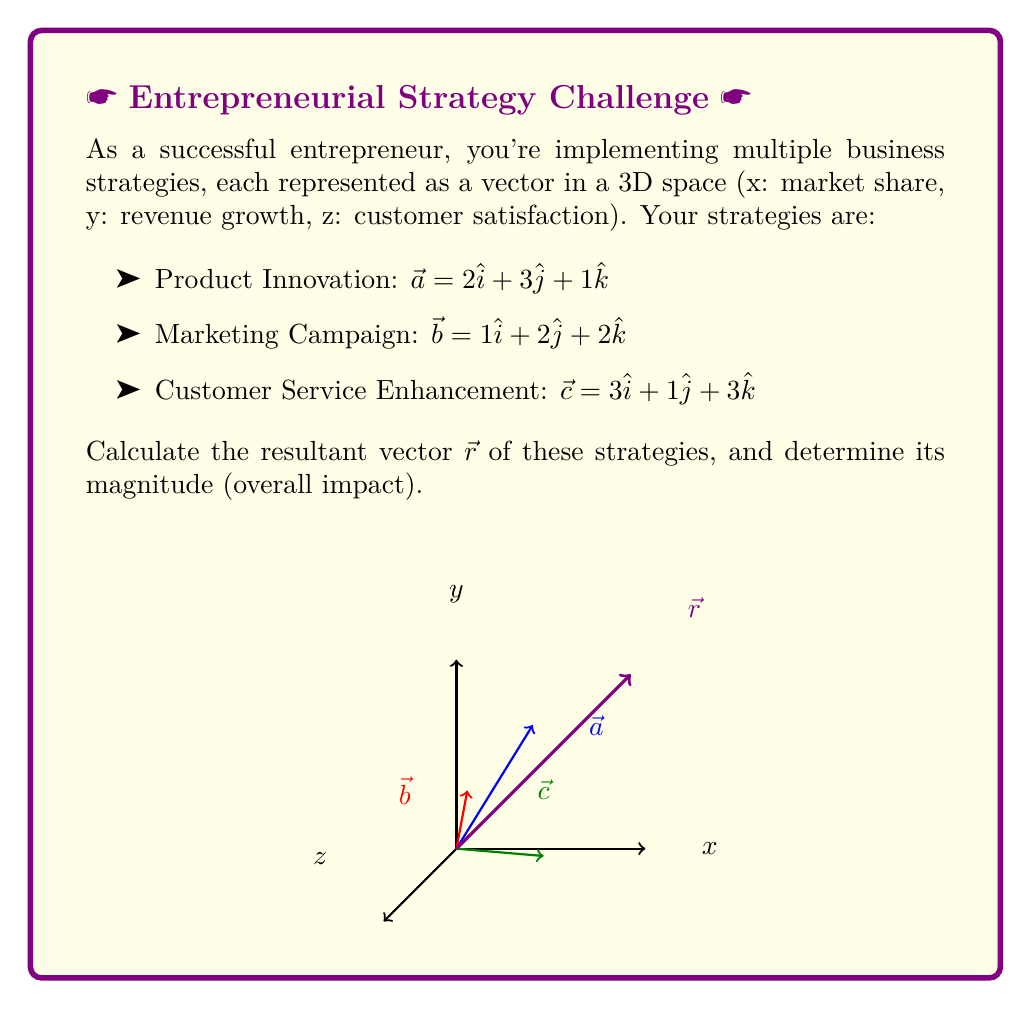Give your solution to this math problem. To solve this problem, we'll follow these steps:

1) First, we need to add the three vectors to find the resultant vector $\vec{r}$:

   $\vec{r} = \vec{a} + \vec{b} + \vec{c}$

2) Let's add the components:

   $\vec{r} = (2\hat{i} + 3\hat{j} + 1\hat{k}) + (1\hat{i} + 2\hat{j} + 2\hat{k}) + (3\hat{i} + 1\hat{j} + 3\hat{k})$

3) Combining like terms:

   $\vec{r} = (2+1+3)\hat{i} + (3+2+1)\hat{j} + (1+2+3)\hat{k}$

4) Simplifying:

   $\vec{r} = 6\hat{i} + 6\hat{j} + 6\hat{k}$

5) To find the magnitude of $\vec{r}$, we use the formula:

   $|\vec{r}| = \sqrt{x^2 + y^2 + z^2}$

   Where x, y, and z are the components of $\vec{r}$.

6) Substituting the values:

   $|\vec{r}| = \sqrt{6^2 + 6^2 + 6^2}$

7) Simplifying:

   $|\vec{r}| = \sqrt{36 + 36 + 36} = \sqrt{108} = 6\sqrt{3}$

Thus, the resultant vector $\vec{r} = 6\hat{i} + 6\hat{j} + 6\hat{k}$ with a magnitude of $6\sqrt{3}$.
Answer: $\vec{r} = 6\hat{i} + 6\hat{j} + 6\hat{k}$, $|\vec{r}| = 6\sqrt{3}$ 